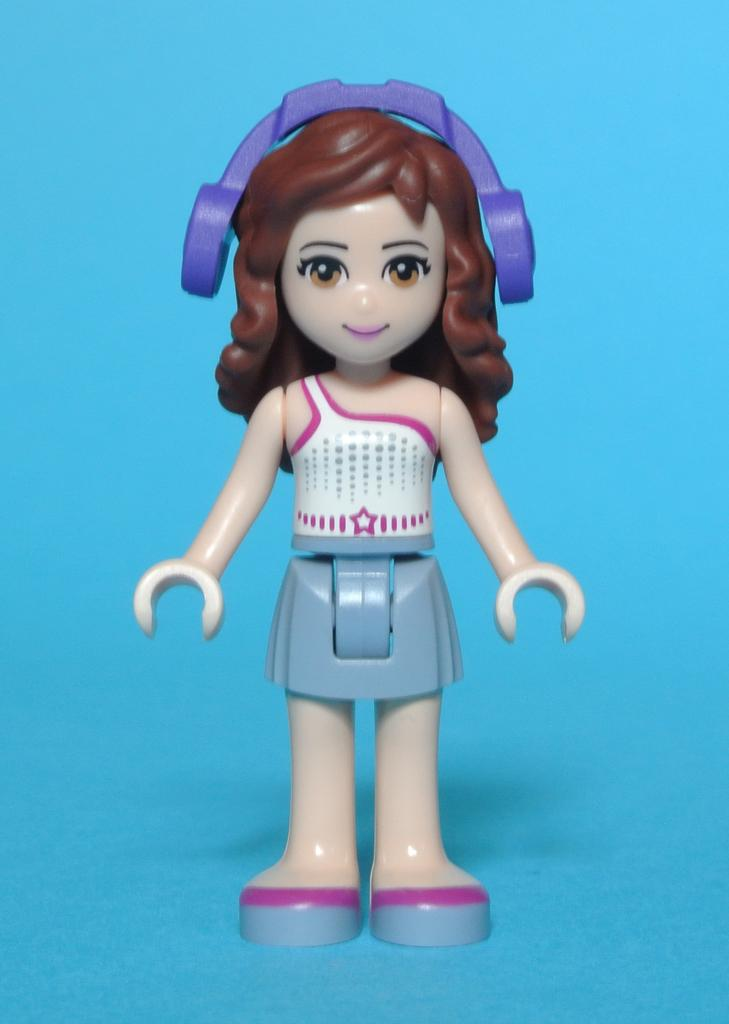What object is present in the image? There is a toy in the image. Can you describe the toy's appearance? The toy has multiple colors. What color is the background of the image? The background of the image is blue. What type of cabbage is being used as a mask in the image? There is no cabbage or mask present in the image. Is there a train visible in the image? No, there is no train present in the image. 